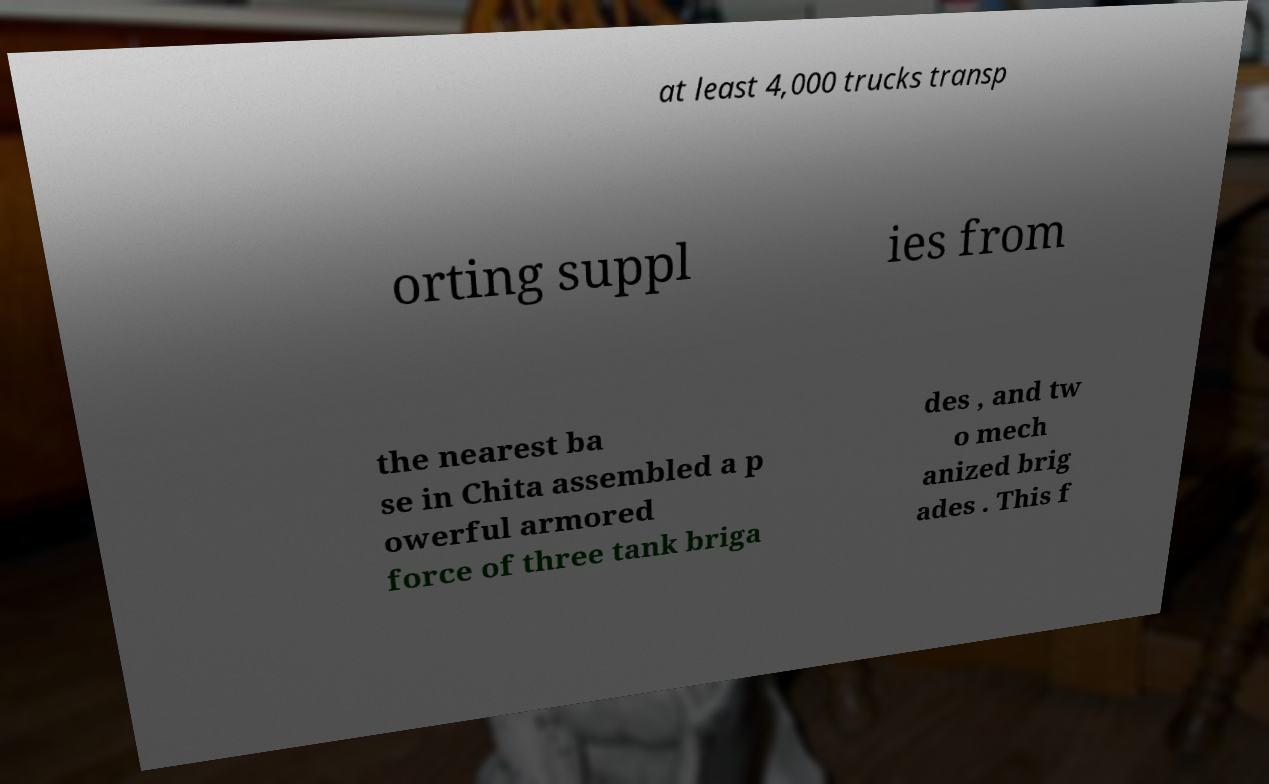Can you accurately transcribe the text from the provided image for me? at least 4,000 trucks transp orting suppl ies from the nearest ba se in Chita assembled a p owerful armored force of three tank briga des , and tw o mech anized brig ades . This f 